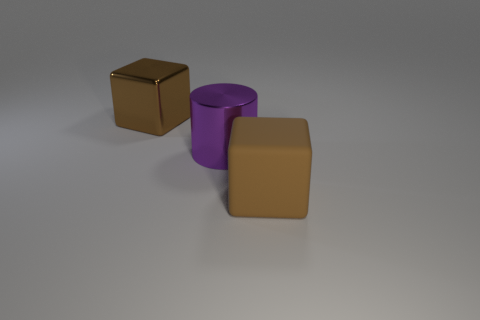Add 2 purple objects. How many objects exist? 5 Subtract all cubes. How many objects are left? 1 Add 1 blue rubber cubes. How many blue rubber cubes exist? 1 Subtract 0 green cylinders. How many objects are left? 3 Subtract all brown objects. Subtract all brown matte cubes. How many objects are left? 0 Add 2 large brown matte things. How many large brown matte things are left? 3 